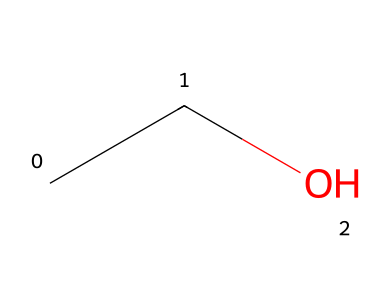What is the name of this chemical? The SMILES representation 'CCO' corresponds to ethanol, commonly known as ethyl alcohol, which is the primary type of alcohol found in alcoholic beverages.
Answer: ethanol How many carbon atoms are in this compound? The SMILES notation 'CCO' indicates there are two 'C' characters, which represent two carbon atoms in the structure of ethanol.
Answer: 2 What type of functional group does this chemical contain? Ethanol contains a hydroxyl group (-OH), which is characteristic of alcohols. In the SMILES 'CCO', the 'O' connected to carbon denotes this functional group.
Answer: hydroxyl What is the total number of hydrogen atoms in ethanol? In the structure represented by 'CCO', each carbon atom is bonded to sufficient hydrogen atoms to satisfy carbon's tetravalency. Thus, with 2 carbon atoms, there are a total of 6 hydrogen atoms.
Answer: 6 Is this compound polar or nonpolar? Ethanol is polar due to the presence of the hydroxyl group (-OH) which creates a dipole moment, making it capable of hydrogen bonding. This characteristic of the -OH group contributes significantly to its polar nature.
Answer: polar What type of reactions can ethanol undergo? Ethanol can undergo oxidation reactions, which can convert it into acetaldehyde or acetic acid depending on the conditions. The presence of the alcohol functional group makes it a susceptible site for such transformations.
Answer: oxidation 